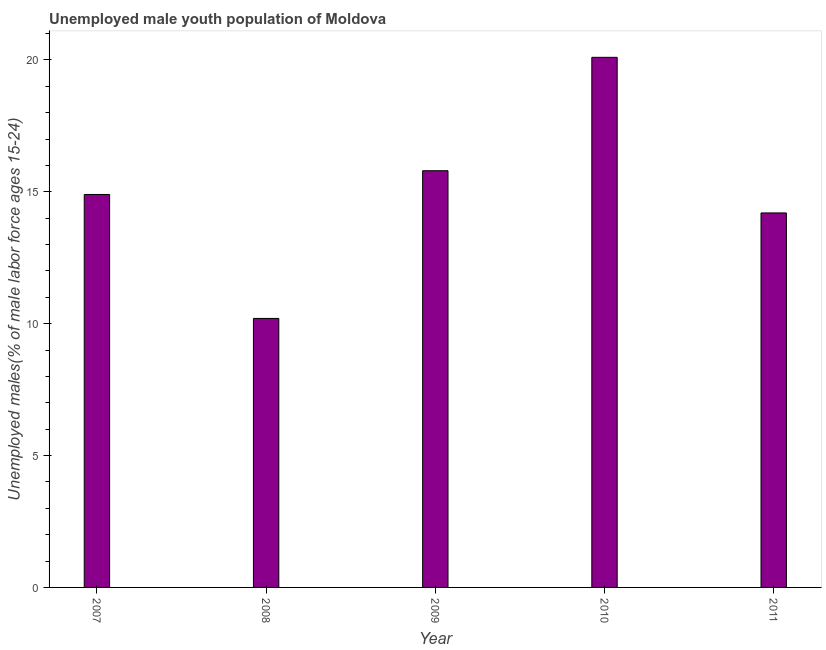What is the title of the graph?
Give a very brief answer. Unemployed male youth population of Moldova. What is the label or title of the Y-axis?
Offer a terse response. Unemployed males(% of male labor force ages 15-24). What is the unemployed male youth in 2007?
Keep it short and to the point. 14.9. Across all years, what is the maximum unemployed male youth?
Your response must be concise. 20.1. Across all years, what is the minimum unemployed male youth?
Your response must be concise. 10.2. In which year was the unemployed male youth minimum?
Offer a very short reply. 2008. What is the sum of the unemployed male youth?
Your answer should be compact. 75.2. What is the average unemployed male youth per year?
Offer a terse response. 15.04. What is the median unemployed male youth?
Offer a very short reply. 14.9. Do a majority of the years between 2008 and 2010 (inclusive) have unemployed male youth greater than 1 %?
Your response must be concise. Yes. What is the ratio of the unemployed male youth in 2008 to that in 2010?
Ensure brevity in your answer.  0.51. In how many years, is the unemployed male youth greater than the average unemployed male youth taken over all years?
Make the answer very short. 2. Are all the bars in the graph horizontal?
Give a very brief answer. No. How many years are there in the graph?
Keep it short and to the point. 5. What is the Unemployed males(% of male labor force ages 15-24) in 2007?
Your answer should be very brief. 14.9. What is the Unemployed males(% of male labor force ages 15-24) of 2008?
Keep it short and to the point. 10.2. What is the Unemployed males(% of male labor force ages 15-24) in 2009?
Provide a short and direct response. 15.8. What is the Unemployed males(% of male labor force ages 15-24) of 2010?
Your answer should be very brief. 20.1. What is the Unemployed males(% of male labor force ages 15-24) in 2011?
Your answer should be compact. 14.2. What is the difference between the Unemployed males(% of male labor force ages 15-24) in 2007 and 2008?
Provide a succinct answer. 4.7. What is the difference between the Unemployed males(% of male labor force ages 15-24) in 2007 and 2009?
Ensure brevity in your answer.  -0.9. What is the difference between the Unemployed males(% of male labor force ages 15-24) in 2007 and 2011?
Ensure brevity in your answer.  0.7. What is the difference between the Unemployed males(% of male labor force ages 15-24) in 2008 and 2009?
Provide a short and direct response. -5.6. What is the difference between the Unemployed males(% of male labor force ages 15-24) in 2009 and 2011?
Your answer should be compact. 1.6. What is the difference between the Unemployed males(% of male labor force ages 15-24) in 2010 and 2011?
Ensure brevity in your answer.  5.9. What is the ratio of the Unemployed males(% of male labor force ages 15-24) in 2007 to that in 2008?
Your response must be concise. 1.46. What is the ratio of the Unemployed males(% of male labor force ages 15-24) in 2007 to that in 2009?
Offer a very short reply. 0.94. What is the ratio of the Unemployed males(% of male labor force ages 15-24) in 2007 to that in 2010?
Keep it short and to the point. 0.74. What is the ratio of the Unemployed males(% of male labor force ages 15-24) in 2007 to that in 2011?
Your response must be concise. 1.05. What is the ratio of the Unemployed males(% of male labor force ages 15-24) in 2008 to that in 2009?
Give a very brief answer. 0.65. What is the ratio of the Unemployed males(% of male labor force ages 15-24) in 2008 to that in 2010?
Your answer should be compact. 0.51. What is the ratio of the Unemployed males(% of male labor force ages 15-24) in 2008 to that in 2011?
Offer a very short reply. 0.72. What is the ratio of the Unemployed males(% of male labor force ages 15-24) in 2009 to that in 2010?
Your answer should be compact. 0.79. What is the ratio of the Unemployed males(% of male labor force ages 15-24) in 2009 to that in 2011?
Provide a short and direct response. 1.11. What is the ratio of the Unemployed males(% of male labor force ages 15-24) in 2010 to that in 2011?
Provide a succinct answer. 1.42. 